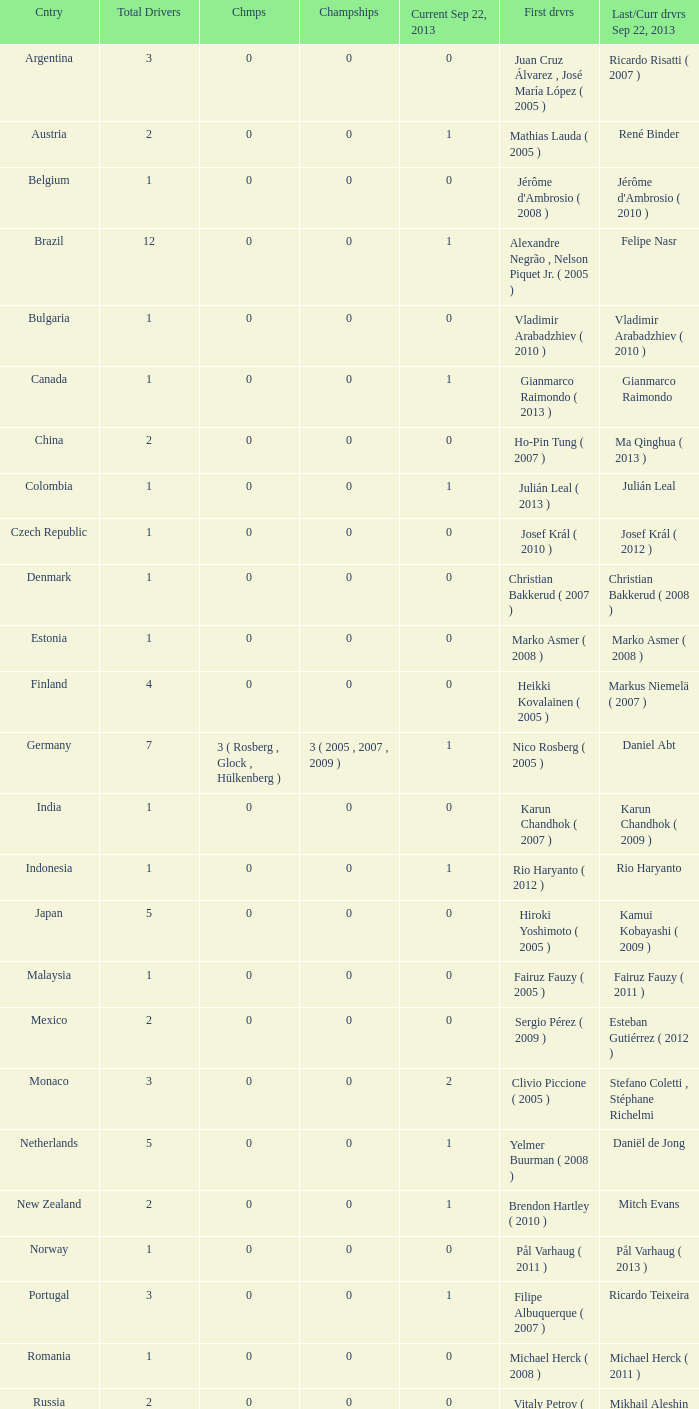How many entries are there for first driver for Canada? 1.0. 